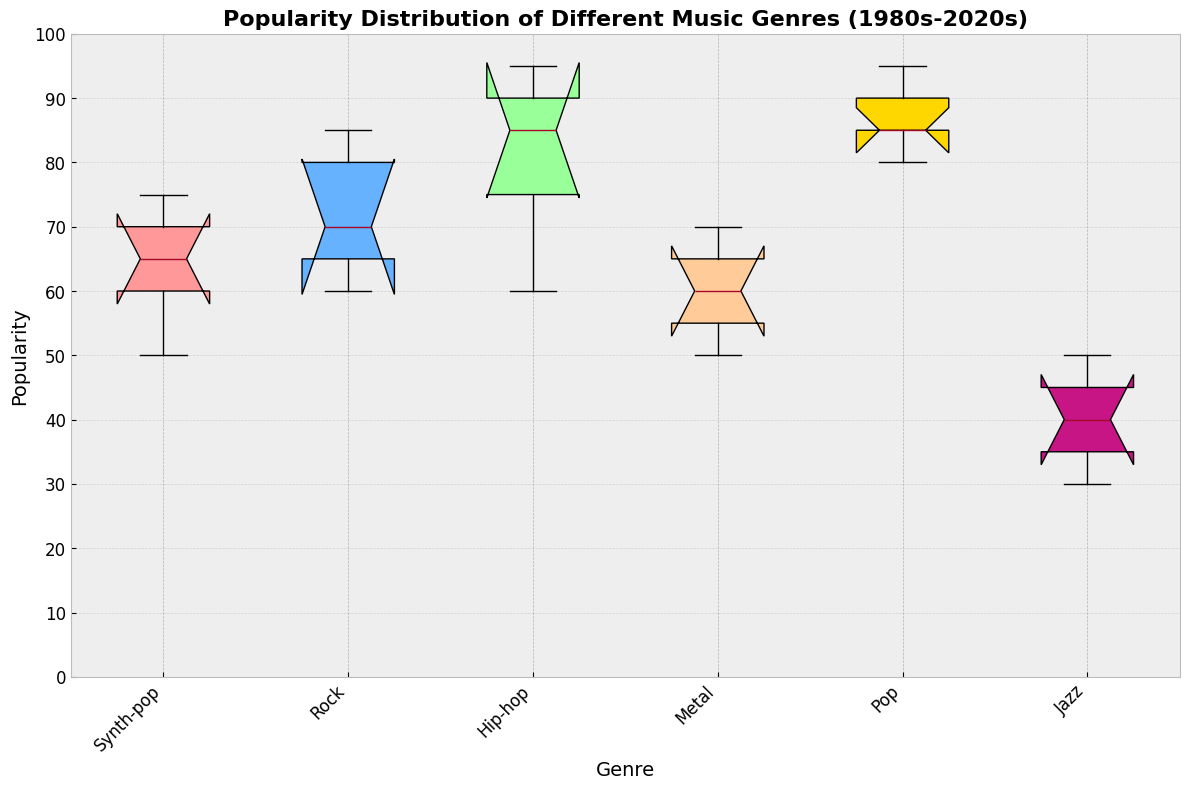What is the range of popularity values for Synth-pop across the decades? To determine the range, subtract the minimum value of popularity from the maximum value for Synth-pop. From the data provided in the box plot, the minimum value for Synth-pop is 50 (2000s) and the maximum value is 75 (1980s). Hence, the range is 75 - 50.
Answer: 25 Among Rock, Hip-hop, and Pop, which genre has the highest median popularity? Look at the box plot and identify the median lines for Rock, Hip-hop, and Pop. Compare these median lines to see which one is positioned higher. Hip-hop's median line is the highest among Rock, Hip-hop, and Pop.
Answer: Hip-hop Which decade shows the widest interquartile range (IQR) for Pop music? Examine the length of the boxes for Pop music in each decade, as the IQR is represented by the height of the box. The 2010s show the widest IQR for Pop music.
Answer: 2010s How does the median popularity of Jazz in the 2020s compare to the 1980s? Locate the median lines for Jazz in both the 2020s and the 1980s. Compare their positions to see which one is higher. The median popularity of Jazz in the 1980s (50) is higher than in the 2020s (30).
Answer: 1980s is higher What is the difference in median popularity between Hip-hop and Metal in the 2000s? Identify the median lines for Hip-hop and Metal in the 2000s. The median popularity for Hip-hop is 85 and for Metal, it is 60. Subtract Metal's median from Hip-hop's median: 85 - 60.
Answer: 25 Which genre has the smallest range of popularity values over the decades? Compare the lengths of the whiskers for all genres. The genre with the shortest whiskers, indicating the smallest range, is Jazz (ranging from 30 to 50).
Answer: Jazz Identify the genre with the most significant decrease in popularity from the 1980s to the 2000s. For each genre, compare the popularity values in the 1980s and the 2000s and calculate the decrease. Synth-pop shows the most significant decrease, dropping from 75 to 50, a change of 25.
Answer: Synth-pop Which genre displays the most consistent popularity (least variation) across decades? The genre with the shortest box and whiskers, indicating the least variation, should be identified. Jazz displays the most consistent popularity as it shows the least variation in its values.
Answer: Jazz Considering Pop music, how does its popularity in the 2010s compare to the 1990s? Look at the data points for Pop music in the 2010s and the 1990s. The 2010s show a popularity value of 95, and the 1990s show 85. Thus, the popularity in the 2010s is higher by 10 points compared to the 1990s.
Answer: Higher in 2010s by 10 points 